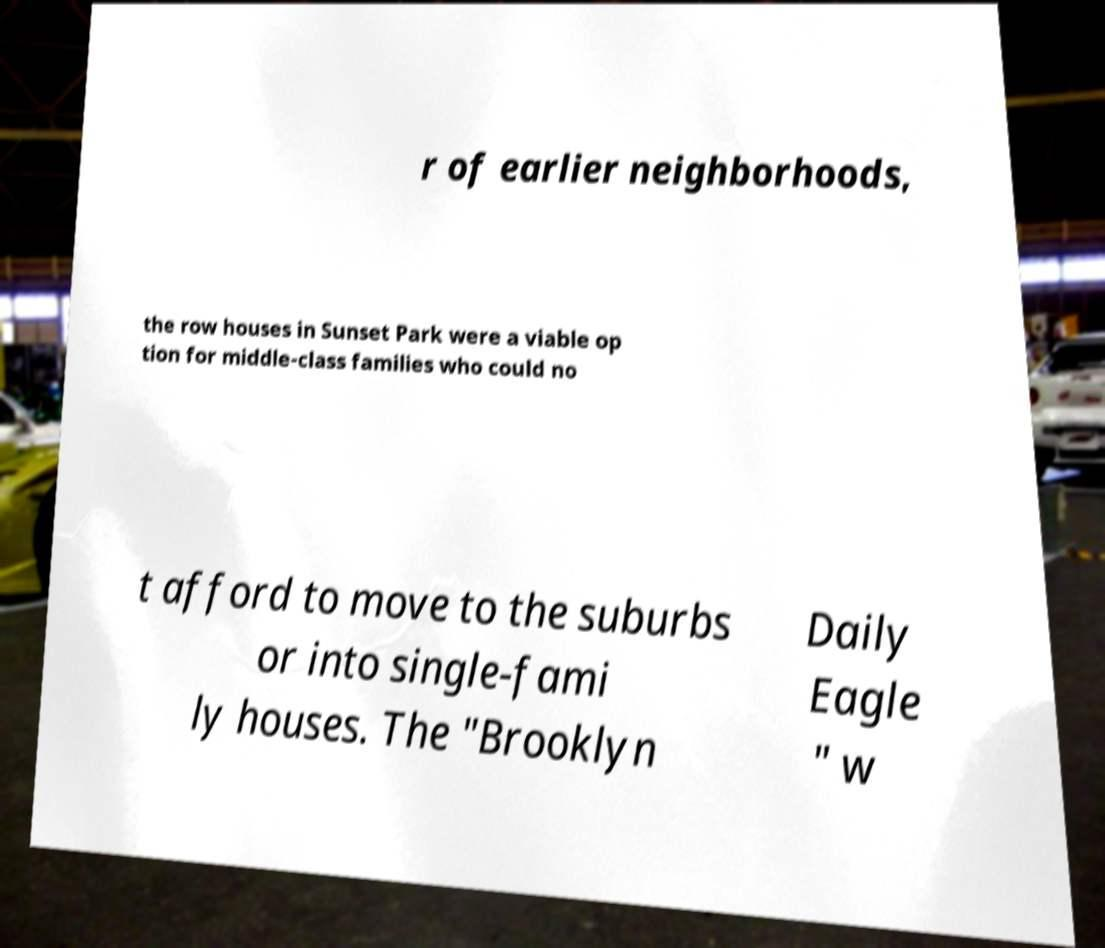I need the written content from this picture converted into text. Can you do that? r of earlier neighborhoods, the row houses in Sunset Park were a viable op tion for middle-class families who could no t afford to move to the suburbs or into single-fami ly houses. The "Brooklyn Daily Eagle " w 